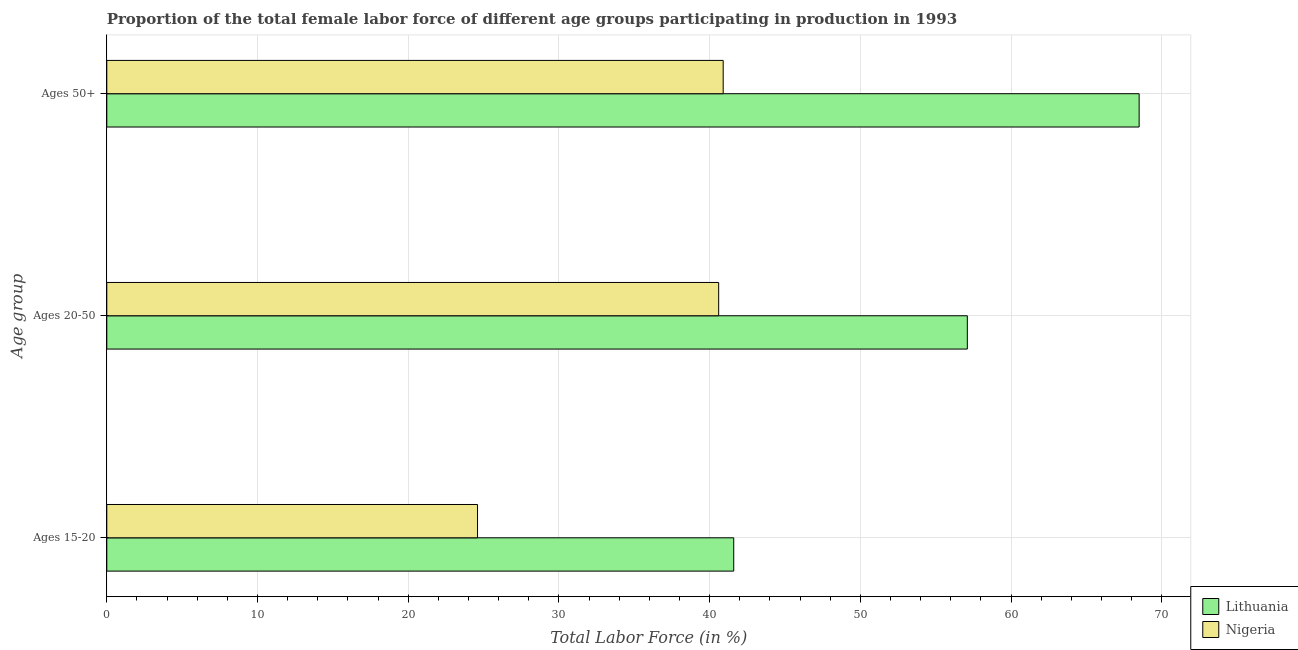Are the number of bars on each tick of the Y-axis equal?
Your answer should be compact. Yes. What is the label of the 2nd group of bars from the top?
Your answer should be compact. Ages 20-50. What is the percentage of female labor force within the age group 20-50 in Nigeria?
Provide a short and direct response. 40.6. Across all countries, what is the maximum percentage of female labor force within the age group 20-50?
Keep it short and to the point. 57.1. Across all countries, what is the minimum percentage of female labor force within the age group 20-50?
Offer a terse response. 40.6. In which country was the percentage of female labor force above age 50 maximum?
Make the answer very short. Lithuania. In which country was the percentage of female labor force within the age group 15-20 minimum?
Offer a terse response. Nigeria. What is the total percentage of female labor force within the age group 20-50 in the graph?
Offer a very short reply. 97.7. What is the difference between the percentage of female labor force above age 50 in Nigeria and that in Lithuania?
Give a very brief answer. -27.6. What is the difference between the percentage of female labor force above age 50 in Lithuania and the percentage of female labor force within the age group 20-50 in Nigeria?
Make the answer very short. 27.9. What is the average percentage of female labor force above age 50 per country?
Your answer should be compact. 54.7. What is the difference between the percentage of female labor force within the age group 15-20 and percentage of female labor force above age 50 in Lithuania?
Provide a succinct answer. -26.9. In how many countries, is the percentage of female labor force within the age group 15-20 greater than 22 %?
Your answer should be very brief. 2. What is the ratio of the percentage of female labor force above age 50 in Nigeria to that in Lithuania?
Give a very brief answer. 0.6. Is the percentage of female labor force within the age group 15-20 in Lithuania less than that in Nigeria?
Give a very brief answer. No. What is the difference between the highest and the second highest percentage of female labor force within the age group 15-20?
Offer a very short reply. 17. What is the difference between the highest and the lowest percentage of female labor force above age 50?
Your answer should be compact. 27.6. In how many countries, is the percentage of female labor force above age 50 greater than the average percentage of female labor force above age 50 taken over all countries?
Make the answer very short. 1. What does the 2nd bar from the top in Ages 50+ represents?
Your answer should be very brief. Lithuania. What does the 1st bar from the bottom in Ages 50+ represents?
Give a very brief answer. Lithuania. Is it the case that in every country, the sum of the percentage of female labor force within the age group 15-20 and percentage of female labor force within the age group 20-50 is greater than the percentage of female labor force above age 50?
Ensure brevity in your answer.  Yes. Are all the bars in the graph horizontal?
Offer a terse response. Yes. How many countries are there in the graph?
Make the answer very short. 2. What is the difference between two consecutive major ticks on the X-axis?
Ensure brevity in your answer.  10. Are the values on the major ticks of X-axis written in scientific E-notation?
Provide a short and direct response. No. Where does the legend appear in the graph?
Ensure brevity in your answer.  Bottom right. How many legend labels are there?
Offer a terse response. 2. How are the legend labels stacked?
Keep it short and to the point. Vertical. What is the title of the graph?
Your answer should be very brief. Proportion of the total female labor force of different age groups participating in production in 1993. What is the label or title of the Y-axis?
Ensure brevity in your answer.  Age group. What is the Total Labor Force (in %) in Lithuania in Ages 15-20?
Ensure brevity in your answer.  41.6. What is the Total Labor Force (in %) of Nigeria in Ages 15-20?
Your answer should be compact. 24.6. What is the Total Labor Force (in %) of Lithuania in Ages 20-50?
Ensure brevity in your answer.  57.1. What is the Total Labor Force (in %) of Nigeria in Ages 20-50?
Your answer should be very brief. 40.6. What is the Total Labor Force (in %) in Lithuania in Ages 50+?
Offer a very short reply. 68.5. What is the Total Labor Force (in %) of Nigeria in Ages 50+?
Keep it short and to the point. 40.9. Across all Age group, what is the maximum Total Labor Force (in %) in Lithuania?
Your response must be concise. 68.5. Across all Age group, what is the maximum Total Labor Force (in %) in Nigeria?
Your response must be concise. 40.9. Across all Age group, what is the minimum Total Labor Force (in %) in Lithuania?
Give a very brief answer. 41.6. Across all Age group, what is the minimum Total Labor Force (in %) in Nigeria?
Provide a short and direct response. 24.6. What is the total Total Labor Force (in %) of Lithuania in the graph?
Your answer should be very brief. 167.2. What is the total Total Labor Force (in %) in Nigeria in the graph?
Offer a very short reply. 106.1. What is the difference between the Total Labor Force (in %) in Lithuania in Ages 15-20 and that in Ages 20-50?
Make the answer very short. -15.5. What is the difference between the Total Labor Force (in %) in Lithuania in Ages 15-20 and that in Ages 50+?
Provide a short and direct response. -26.9. What is the difference between the Total Labor Force (in %) of Nigeria in Ages 15-20 and that in Ages 50+?
Give a very brief answer. -16.3. What is the difference between the Total Labor Force (in %) of Lithuania in Ages 20-50 and that in Ages 50+?
Offer a terse response. -11.4. What is the difference between the Total Labor Force (in %) in Nigeria in Ages 20-50 and that in Ages 50+?
Your answer should be compact. -0.3. What is the difference between the Total Labor Force (in %) in Lithuania in Ages 15-20 and the Total Labor Force (in %) in Nigeria in Ages 20-50?
Your answer should be very brief. 1. What is the difference between the Total Labor Force (in %) in Lithuania in Ages 15-20 and the Total Labor Force (in %) in Nigeria in Ages 50+?
Ensure brevity in your answer.  0.7. What is the average Total Labor Force (in %) in Lithuania per Age group?
Give a very brief answer. 55.73. What is the average Total Labor Force (in %) of Nigeria per Age group?
Give a very brief answer. 35.37. What is the difference between the Total Labor Force (in %) in Lithuania and Total Labor Force (in %) in Nigeria in Ages 20-50?
Give a very brief answer. 16.5. What is the difference between the Total Labor Force (in %) in Lithuania and Total Labor Force (in %) in Nigeria in Ages 50+?
Offer a very short reply. 27.6. What is the ratio of the Total Labor Force (in %) in Lithuania in Ages 15-20 to that in Ages 20-50?
Provide a succinct answer. 0.73. What is the ratio of the Total Labor Force (in %) of Nigeria in Ages 15-20 to that in Ages 20-50?
Offer a terse response. 0.61. What is the ratio of the Total Labor Force (in %) of Lithuania in Ages 15-20 to that in Ages 50+?
Your response must be concise. 0.61. What is the ratio of the Total Labor Force (in %) in Nigeria in Ages 15-20 to that in Ages 50+?
Offer a very short reply. 0.6. What is the ratio of the Total Labor Force (in %) in Lithuania in Ages 20-50 to that in Ages 50+?
Give a very brief answer. 0.83. What is the ratio of the Total Labor Force (in %) of Nigeria in Ages 20-50 to that in Ages 50+?
Provide a short and direct response. 0.99. What is the difference between the highest and the second highest Total Labor Force (in %) in Lithuania?
Ensure brevity in your answer.  11.4. What is the difference between the highest and the lowest Total Labor Force (in %) of Lithuania?
Ensure brevity in your answer.  26.9. What is the difference between the highest and the lowest Total Labor Force (in %) in Nigeria?
Provide a succinct answer. 16.3. 